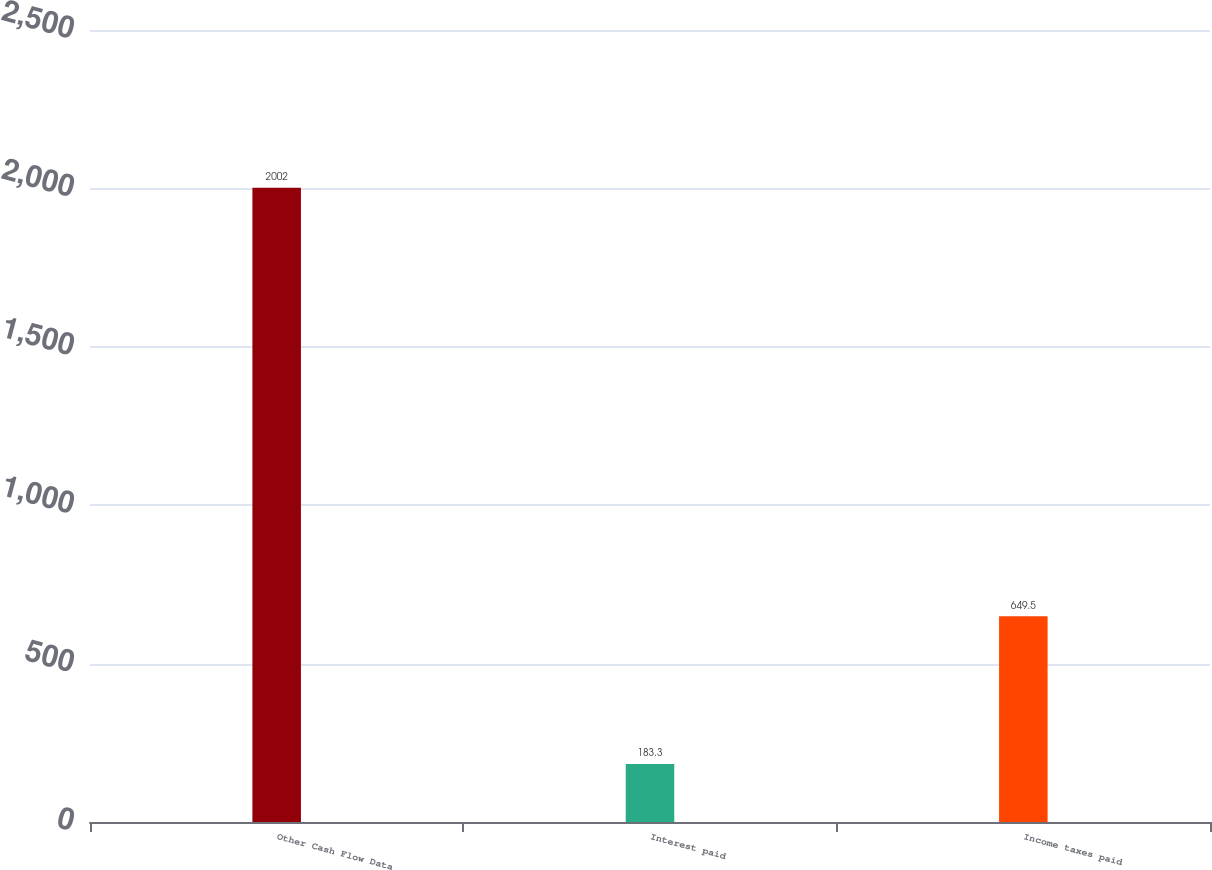Convert chart to OTSL. <chart><loc_0><loc_0><loc_500><loc_500><bar_chart><fcel>Other Cash Flow Data<fcel>Interest paid<fcel>Income taxes paid<nl><fcel>2002<fcel>183.3<fcel>649.5<nl></chart> 